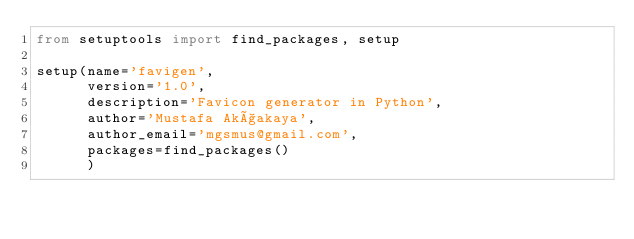<code> <loc_0><loc_0><loc_500><loc_500><_Python_>from setuptools import find_packages, setup

setup(name='favigen',
      version='1.0',
      description='Favicon generator in Python',
      author='Mustafa Akçakaya',
      author_email='mgsmus@gmail.com',
      packages=find_packages()
      )
</code> 